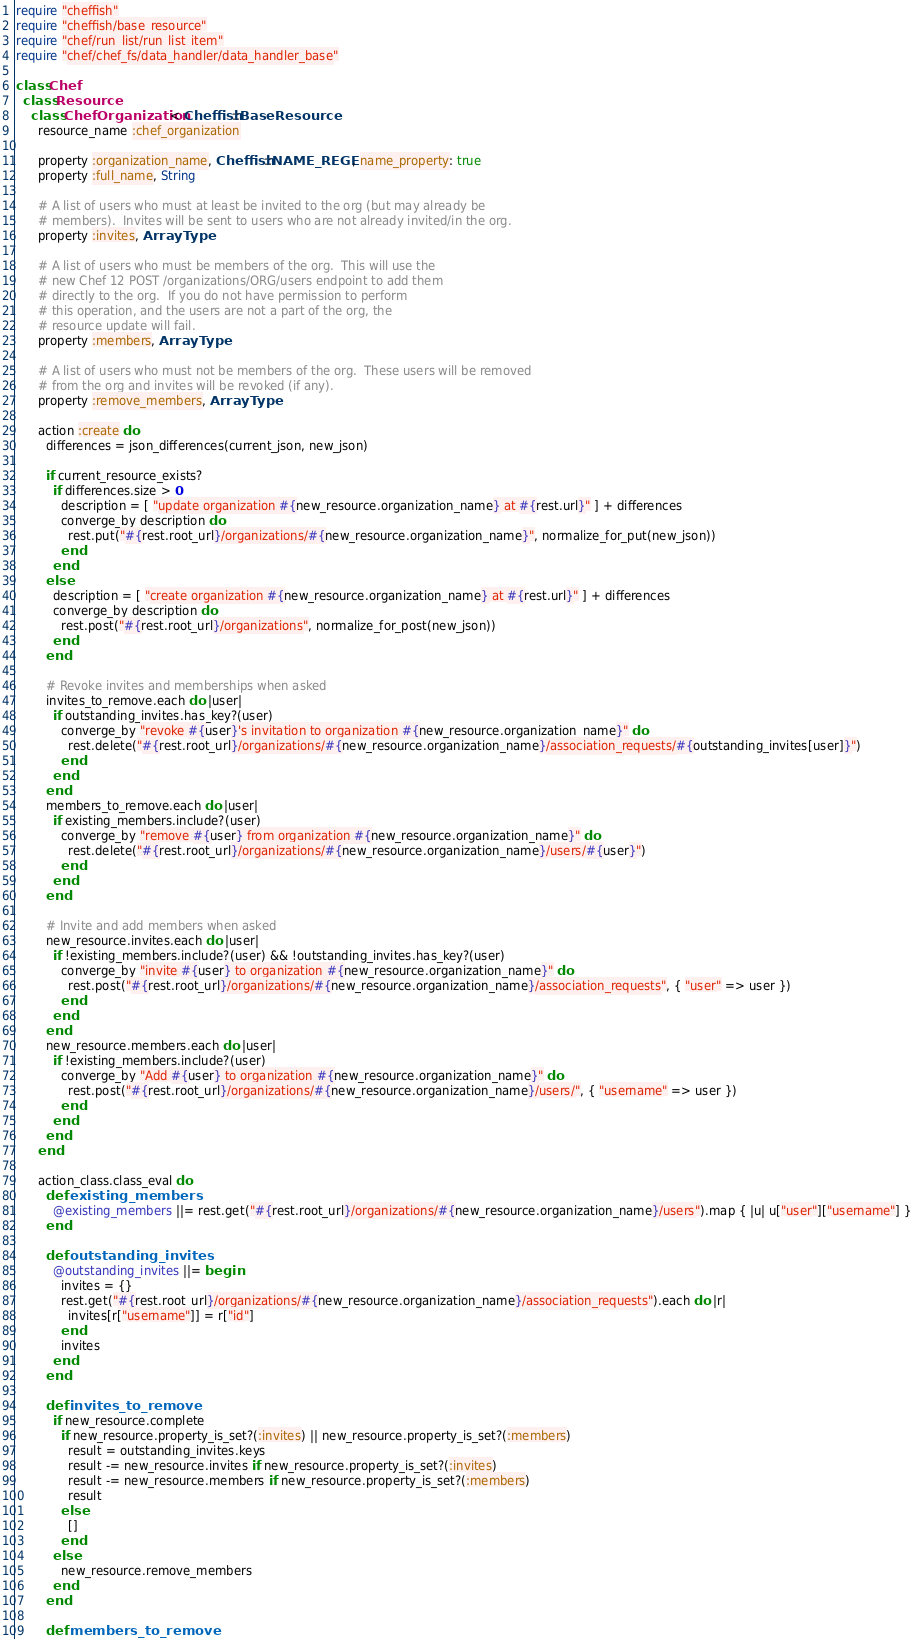<code> <loc_0><loc_0><loc_500><loc_500><_Ruby_>require "cheffish"
require "cheffish/base_resource"
require "chef/run_list/run_list_item"
require "chef/chef_fs/data_handler/data_handler_base"

class Chef
  class Resource
    class ChefOrganization < Cheffish::BaseResource
      resource_name :chef_organization

      property :organization_name, Cheffish::NAME_REGEX, name_property: true
      property :full_name, String

      # A list of users who must at least be invited to the org (but may already be
      # members).  Invites will be sent to users who are not already invited/in the org.
      property :invites, ArrayType

      # A list of users who must be members of the org.  This will use the
      # new Chef 12 POST /organizations/ORG/users endpoint to add them
      # directly to the org.  If you do not have permission to perform
      # this operation, and the users are not a part of the org, the
      # resource update will fail.
      property :members, ArrayType

      # A list of users who must not be members of the org.  These users will be removed
      # from the org and invites will be revoked (if any).
      property :remove_members, ArrayType

      action :create do
        differences = json_differences(current_json, new_json)

        if current_resource_exists?
          if differences.size > 0
            description = [ "update organization #{new_resource.organization_name} at #{rest.url}" ] + differences
            converge_by description do
              rest.put("#{rest.root_url}/organizations/#{new_resource.organization_name}", normalize_for_put(new_json))
            end
          end
        else
          description = [ "create organization #{new_resource.organization_name} at #{rest.url}" ] + differences
          converge_by description do
            rest.post("#{rest.root_url}/organizations", normalize_for_post(new_json))
          end
        end

        # Revoke invites and memberships when asked
        invites_to_remove.each do |user|
          if outstanding_invites.has_key?(user)
            converge_by "revoke #{user}'s invitation to organization #{new_resource.organization_name}" do
              rest.delete("#{rest.root_url}/organizations/#{new_resource.organization_name}/association_requests/#{outstanding_invites[user]}")
            end
          end
        end
        members_to_remove.each do |user|
          if existing_members.include?(user)
            converge_by "remove #{user} from organization #{new_resource.organization_name}" do
              rest.delete("#{rest.root_url}/organizations/#{new_resource.organization_name}/users/#{user}")
            end
          end
        end

        # Invite and add members when asked
        new_resource.invites.each do |user|
          if !existing_members.include?(user) && !outstanding_invites.has_key?(user)
            converge_by "invite #{user} to organization #{new_resource.organization_name}" do
              rest.post("#{rest.root_url}/organizations/#{new_resource.organization_name}/association_requests", { "user" => user })
            end
          end
        end
        new_resource.members.each do |user|
          if !existing_members.include?(user)
            converge_by "Add #{user} to organization #{new_resource.organization_name}" do
              rest.post("#{rest.root_url}/organizations/#{new_resource.organization_name}/users/", { "username" => user })
            end
          end
        end
      end

      action_class.class_eval do
        def existing_members
          @existing_members ||= rest.get("#{rest.root_url}/organizations/#{new_resource.organization_name}/users").map { |u| u["user"]["username"] }
        end

        def outstanding_invites
          @outstanding_invites ||= begin
            invites = {}
            rest.get("#{rest.root_url}/organizations/#{new_resource.organization_name}/association_requests").each do |r|
              invites[r["username"]] = r["id"]
            end
            invites
          end
        end

        def invites_to_remove
          if new_resource.complete
            if new_resource.property_is_set?(:invites) || new_resource.property_is_set?(:members)
              result = outstanding_invites.keys
              result -= new_resource.invites if new_resource.property_is_set?(:invites)
              result -= new_resource.members if new_resource.property_is_set?(:members)
              result
            else
              []
            end
          else
            new_resource.remove_members
          end
        end

        def members_to_remove</code> 